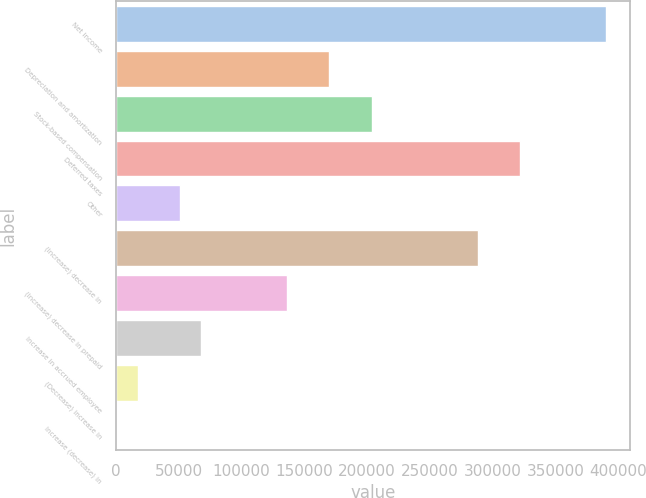Convert chart. <chart><loc_0><loc_0><loc_500><loc_500><bar_chart><fcel>Net income<fcel>Depreciation and amortization<fcel>Stock-based compensation<fcel>Deferred taxes<fcel>Other<fcel>(Increase) decrease in<fcel>(Increase) decrease in prepaid<fcel>Increase in accrued employee<fcel>(Decrease) increase in<fcel>Increase (decrease) in<nl><fcel>389895<fcel>169620<fcel>203508<fcel>322118<fcel>51010.6<fcel>288229<fcel>135732<fcel>67954.8<fcel>17122.2<fcel>178<nl></chart> 